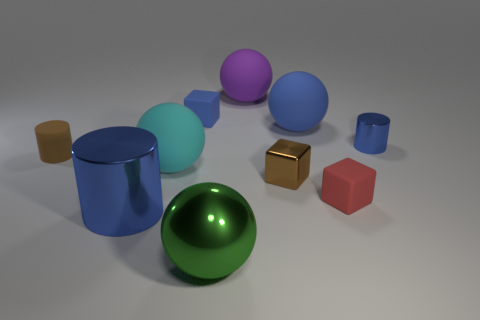Subtract all blocks. How many objects are left? 7 Subtract all tiny cyan cubes. Subtract all tiny brown shiny blocks. How many objects are left? 9 Add 7 green shiny things. How many green shiny things are left? 8 Add 1 large purple spheres. How many large purple spheres exist? 2 Subtract 0 purple cylinders. How many objects are left? 10 